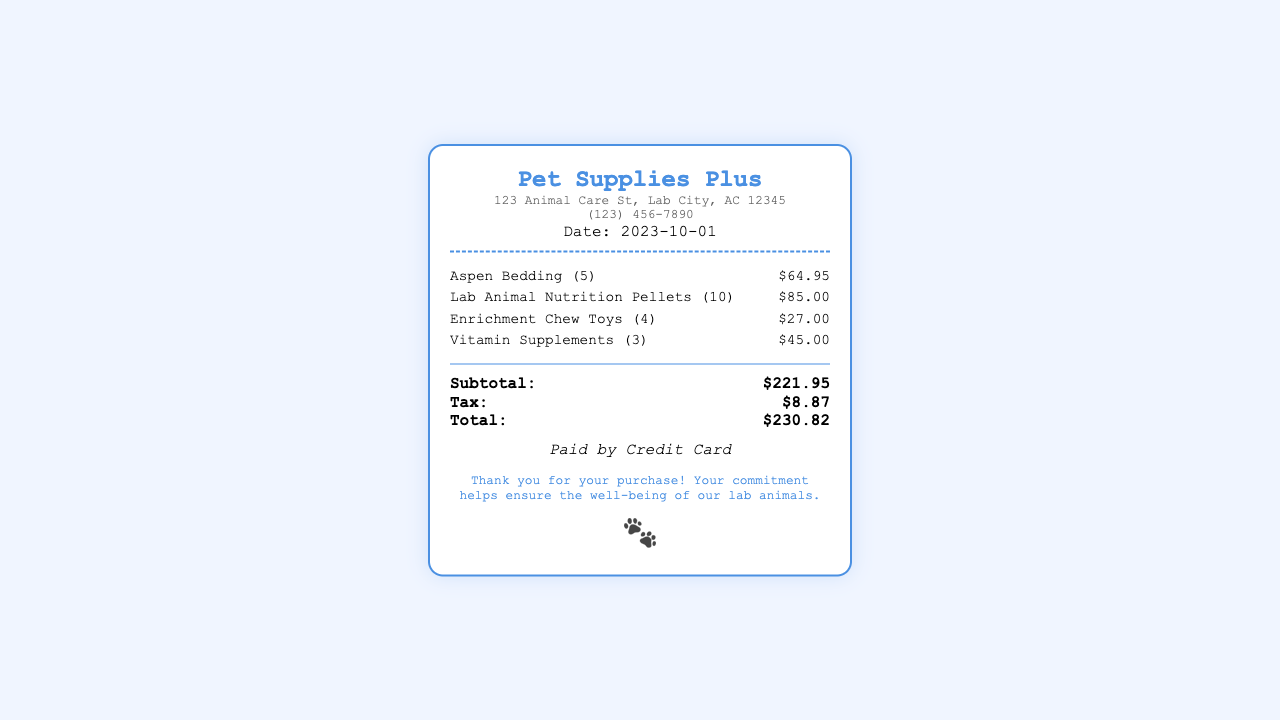what is the store name? The store name is prominently displayed at the top of the receipt.
Answer: Pet Supplies Plus what is the date of purchase? The date is mentioned below the store details in the receipt.
Answer: 2023-10-01 how much did the Aspen Bedding cost? The cost of the Aspen Bedding is listed with the item in the receipt.
Answer: $64.95 what items were purchased? The items purchased are listed in detail under the items section.
Answer: Aspen Bedding, Lab Animal Nutrition Pellets, Enrichment Chew Toys, Vitamin Supplements what is the subtotal of the items? The subtotal is computed as the sum of all item costs before tax.
Answer: $221.95 how much tax was charged? The tax amount is specified in the totals section of the receipt.
Answer: $8.87 what is the total amount paid? The total amount is calculated by adding the subtotal and tax together.
Answer: $230.82 how was the payment made? The payment method is mentioned towards the bottom of the receipt.
Answer: Credit Card how many enrichment chew toys were purchased? The number of enrichment chew toys is specified in the item description.
Answer: 4 